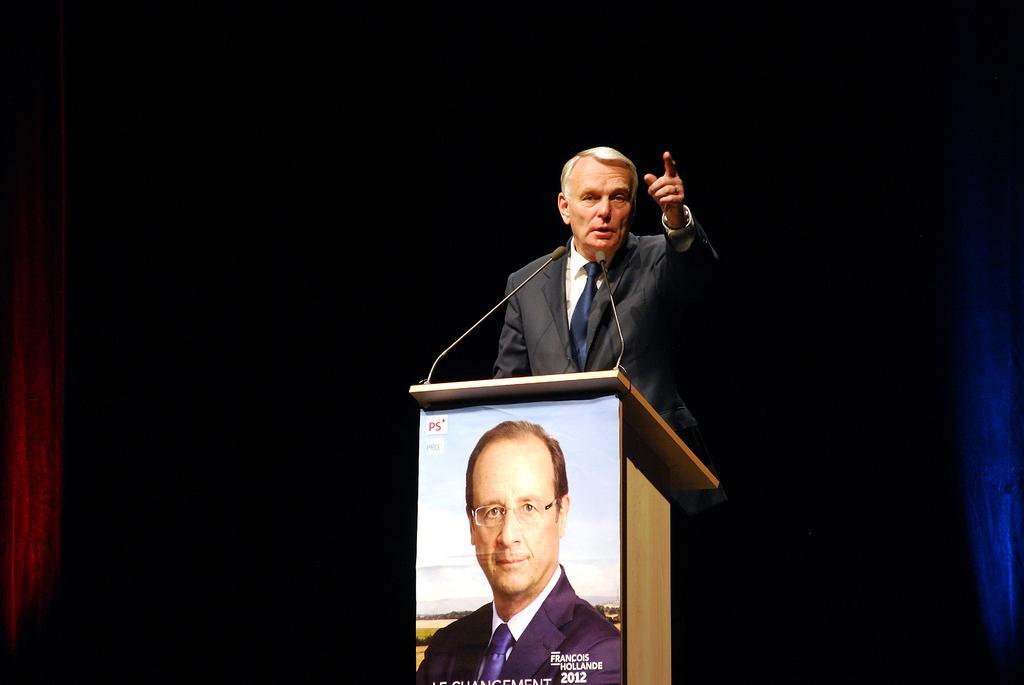Describe this image in one or two sentences. In this image I can see a man is standing and I can see he is wearing formal dress. Here I can see a podium, few mics and a poster of a man. 